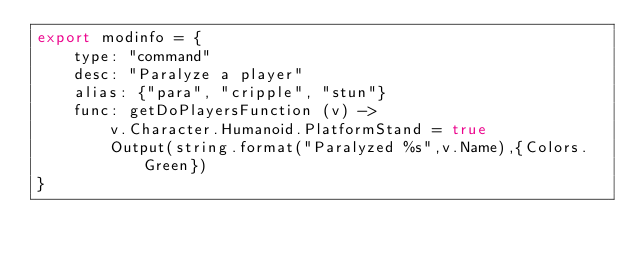<code> <loc_0><loc_0><loc_500><loc_500><_MoonScript_>export modinfo = {
	type: "command"
	desc: "Paralyze a player"
	alias: {"para", "cripple", "stun"}
	func: getDoPlayersFunction (v) ->
		v.Character.Humanoid.PlatformStand = true
		Output(string.format("Paralyzed %s",v.Name),{Colors.Green})
}</code> 